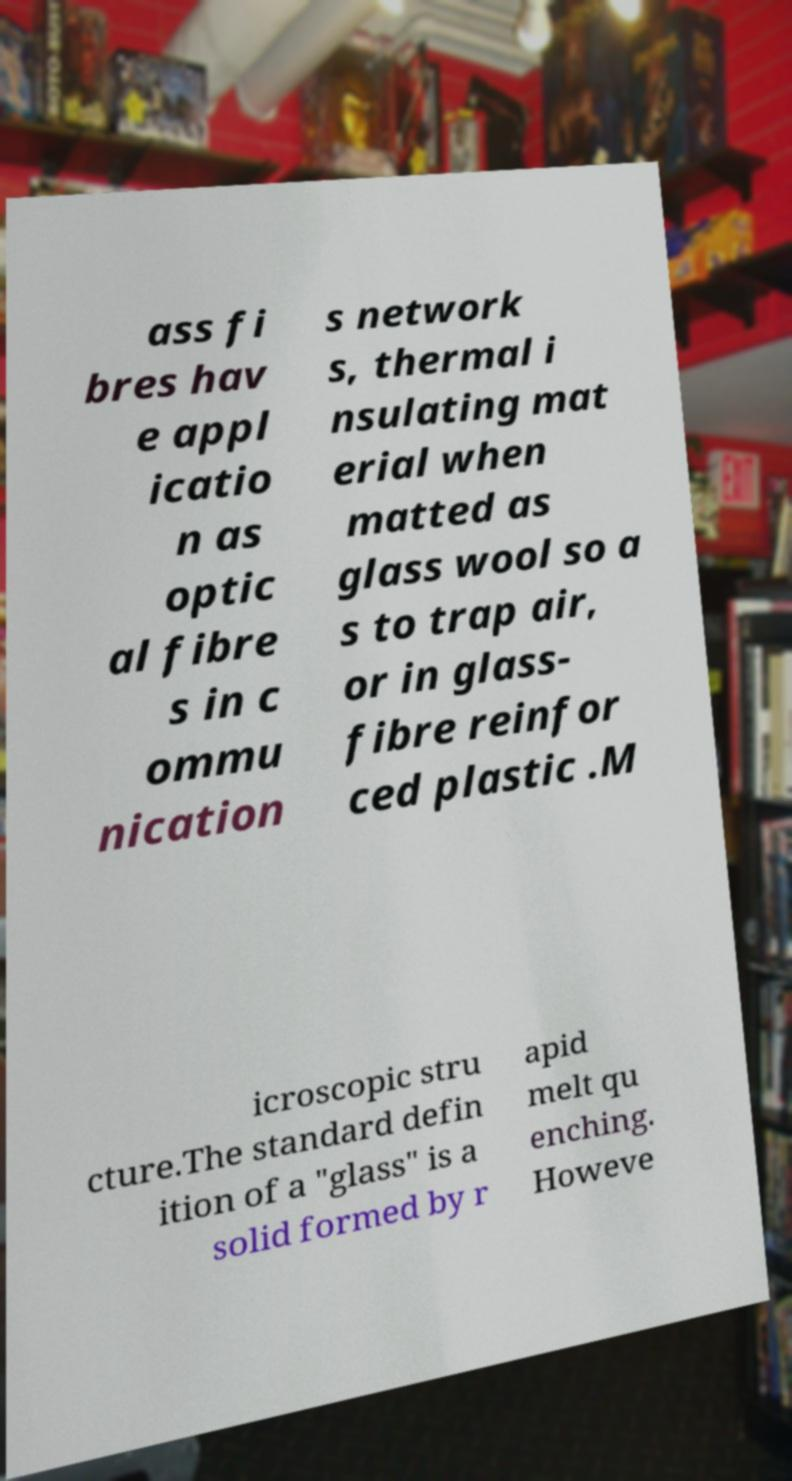Please identify and transcribe the text found in this image. ass fi bres hav e appl icatio n as optic al fibre s in c ommu nication s network s, thermal i nsulating mat erial when matted as glass wool so a s to trap air, or in glass- fibre reinfor ced plastic .M icroscopic stru cture.The standard defin ition of a "glass" is a solid formed by r apid melt qu enching. Howeve 